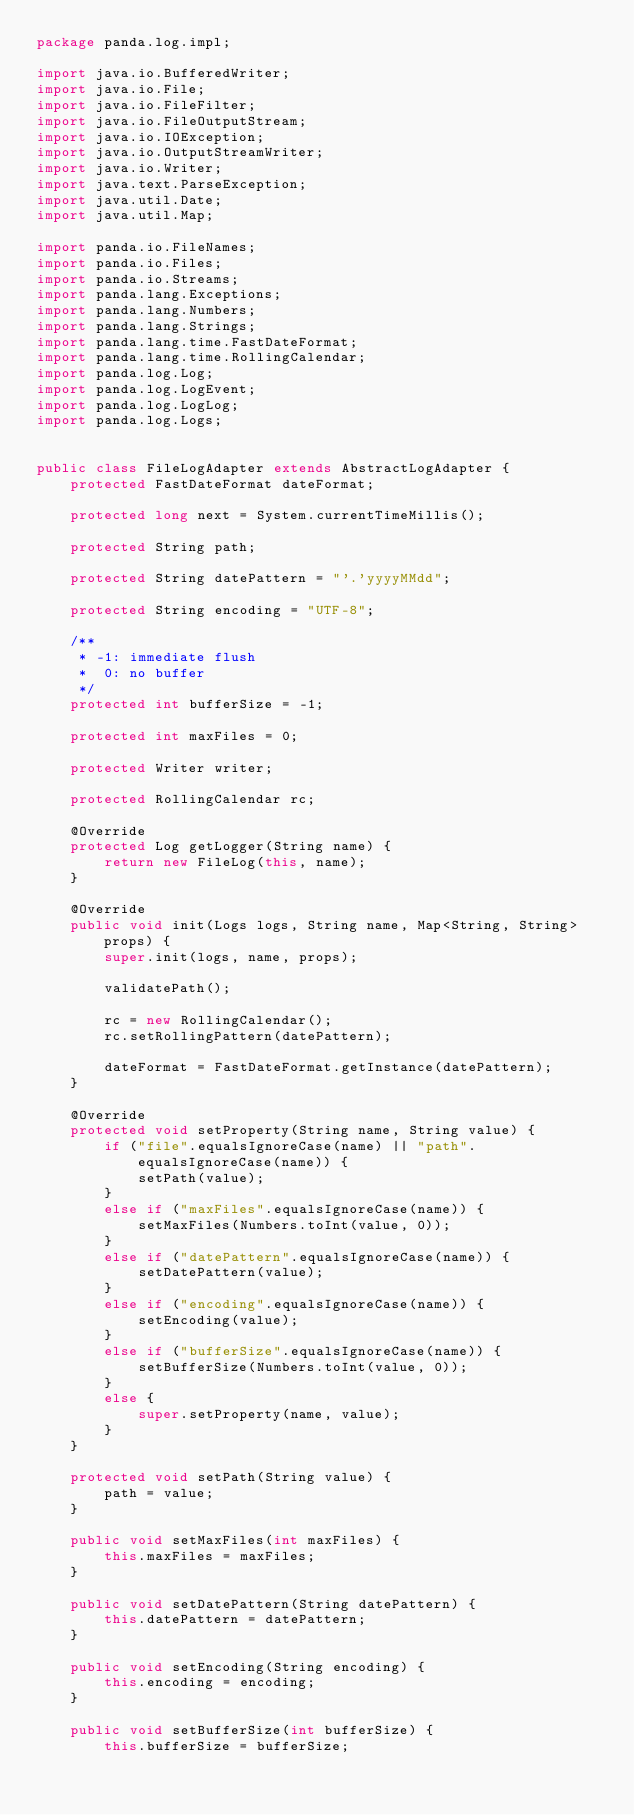Convert code to text. <code><loc_0><loc_0><loc_500><loc_500><_Java_>package panda.log.impl;

import java.io.BufferedWriter;
import java.io.File;
import java.io.FileFilter;
import java.io.FileOutputStream;
import java.io.IOException;
import java.io.OutputStreamWriter;
import java.io.Writer;
import java.text.ParseException;
import java.util.Date;
import java.util.Map;

import panda.io.FileNames;
import panda.io.Files;
import panda.io.Streams;
import panda.lang.Exceptions;
import panda.lang.Numbers;
import panda.lang.Strings;
import panda.lang.time.FastDateFormat;
import panda.lang.time.RollingCalendar;
import panda.log.Log;
import panda.log.LogEvent;
import panda.log.LogLog;
import panda.log.Logs;


public class FileLogAdapter extends AbstractLogAdapter {
	protected FastDateFormat dateFormat;

	protected long next = System.currentTimeMillis();
	
	protected String path;

	protected String datePattern = "'.'yyyyMMdd";
	
	protected String encoding = "UTF-8";
	
	/**
	 * -1: immediate flush
	 *  0: no buffer
	 */
	protected int bufferSize = -1;
	
	protected int maxFiles = 0;
	
	protected Writer writer;
	
	protected RollingCalendar rc;
	
	@Override
	protected Log getLogger(String name) {
		return new FileLog(this, name);
	}

	@Override
	public void init(Logs logs, String name, Map<String, String> props) {
		super.init(logs, name, props);
		
		validatePath();

		rc = new RollingCalendar();
		rc.setRollingPattern(datePattern);

		dateFormat = FastDateFormat.getInstance(datePattern);
	}

	@Override
	protected void setProperty(String name, String value) {
		if ("file".equalsIgnoreCase(name) || "path".equalsIgnoreCase(name)) {
			setPath(value);
		}
		else if ("maxFiles".equalsIgnoreCase(name)) {
			setMaxFiles(Numbers.toInt(value, 0));
		}
		else if ("datePattern".equalsIgnoreCase(name)) {
			setDatePattern(value);
		}
		else if ("encoding".equalsIgnoreCase(name)) {
			setEncoding(value);
		}
		else if ("bufferSize".equalsIgnoreCase(name)) {
			setBufferSize(Numbers.toInt(value, 0));
		}
		else {
			super.setProperty(name, value);
		}
	}

	protected void setPath(String value) {
		path = value;
	}

	public void setMaxFiles(int maxFiles) {
		this.maxFiles = maxFiles;
	}

	public void setDatePattern(String datePattern) {
		this.datePattern = datePattern;
	}

	public void setEncoding(String encoding) {
		this.encoding = encoding;
	}

	public void setBufferSize(int bufferSize) {
		this.bufferSize = bufferSize;</code> 